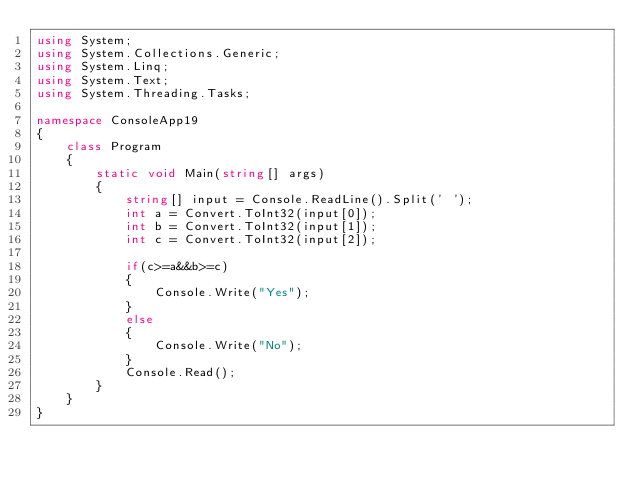Convert code to text. <code><loc_0><loc_0><loc_500><loc_500><_C#_>using System;
using System.Collections.Generic;
using System.Linq;
using System.Text;
using System.Threading.Tasks;

namespace ConsoleApp19
{
    class Program
    {
        static void Main(string[] args)
        {
            string[] input = Console.ReadLine().Split(' ');
            int a = Convert.ToInt32(input[0]);
            int b = Convert.ToInt32(input[1]);
            int c = Convert.ToInt32(input[2]);

            if(c>=a&&b>=c)
            {
                Console.Write("Yes");
            }
            else
            {
                Console.Write("No");
            }
            Console.Read();
        }
    }
}
</code> 